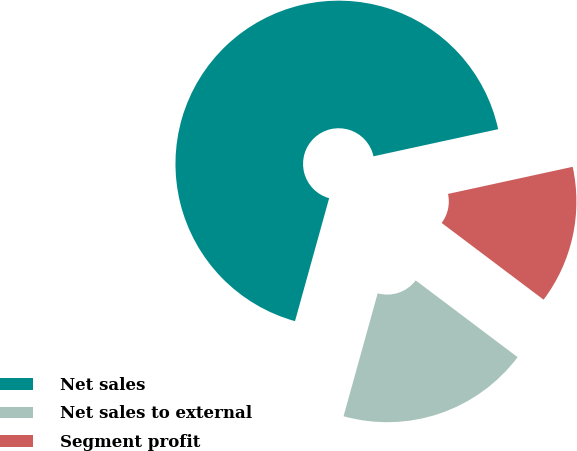Convert chart. <chart><loc_0><loc_0><loc_500><loc_500><pie_chart><fcel>Net sales<fcel>Net sales to external<fcel>Segment profit<nl><fcel>67.28%<fcel>19.04%<fcel>13.68%<nl></chart> 